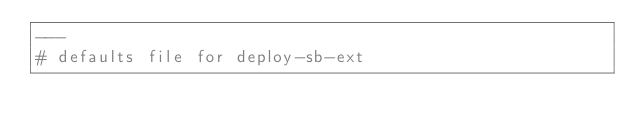Convert code to text. <code><loc_0><loc_0><loc_500><loc_500><_YAML_>---
# defaults file for deploy-sb-ext</code> 